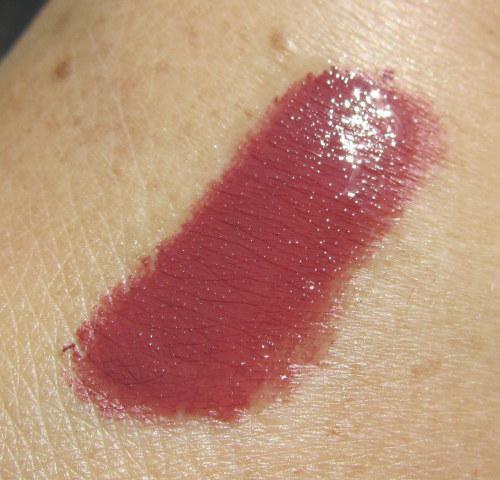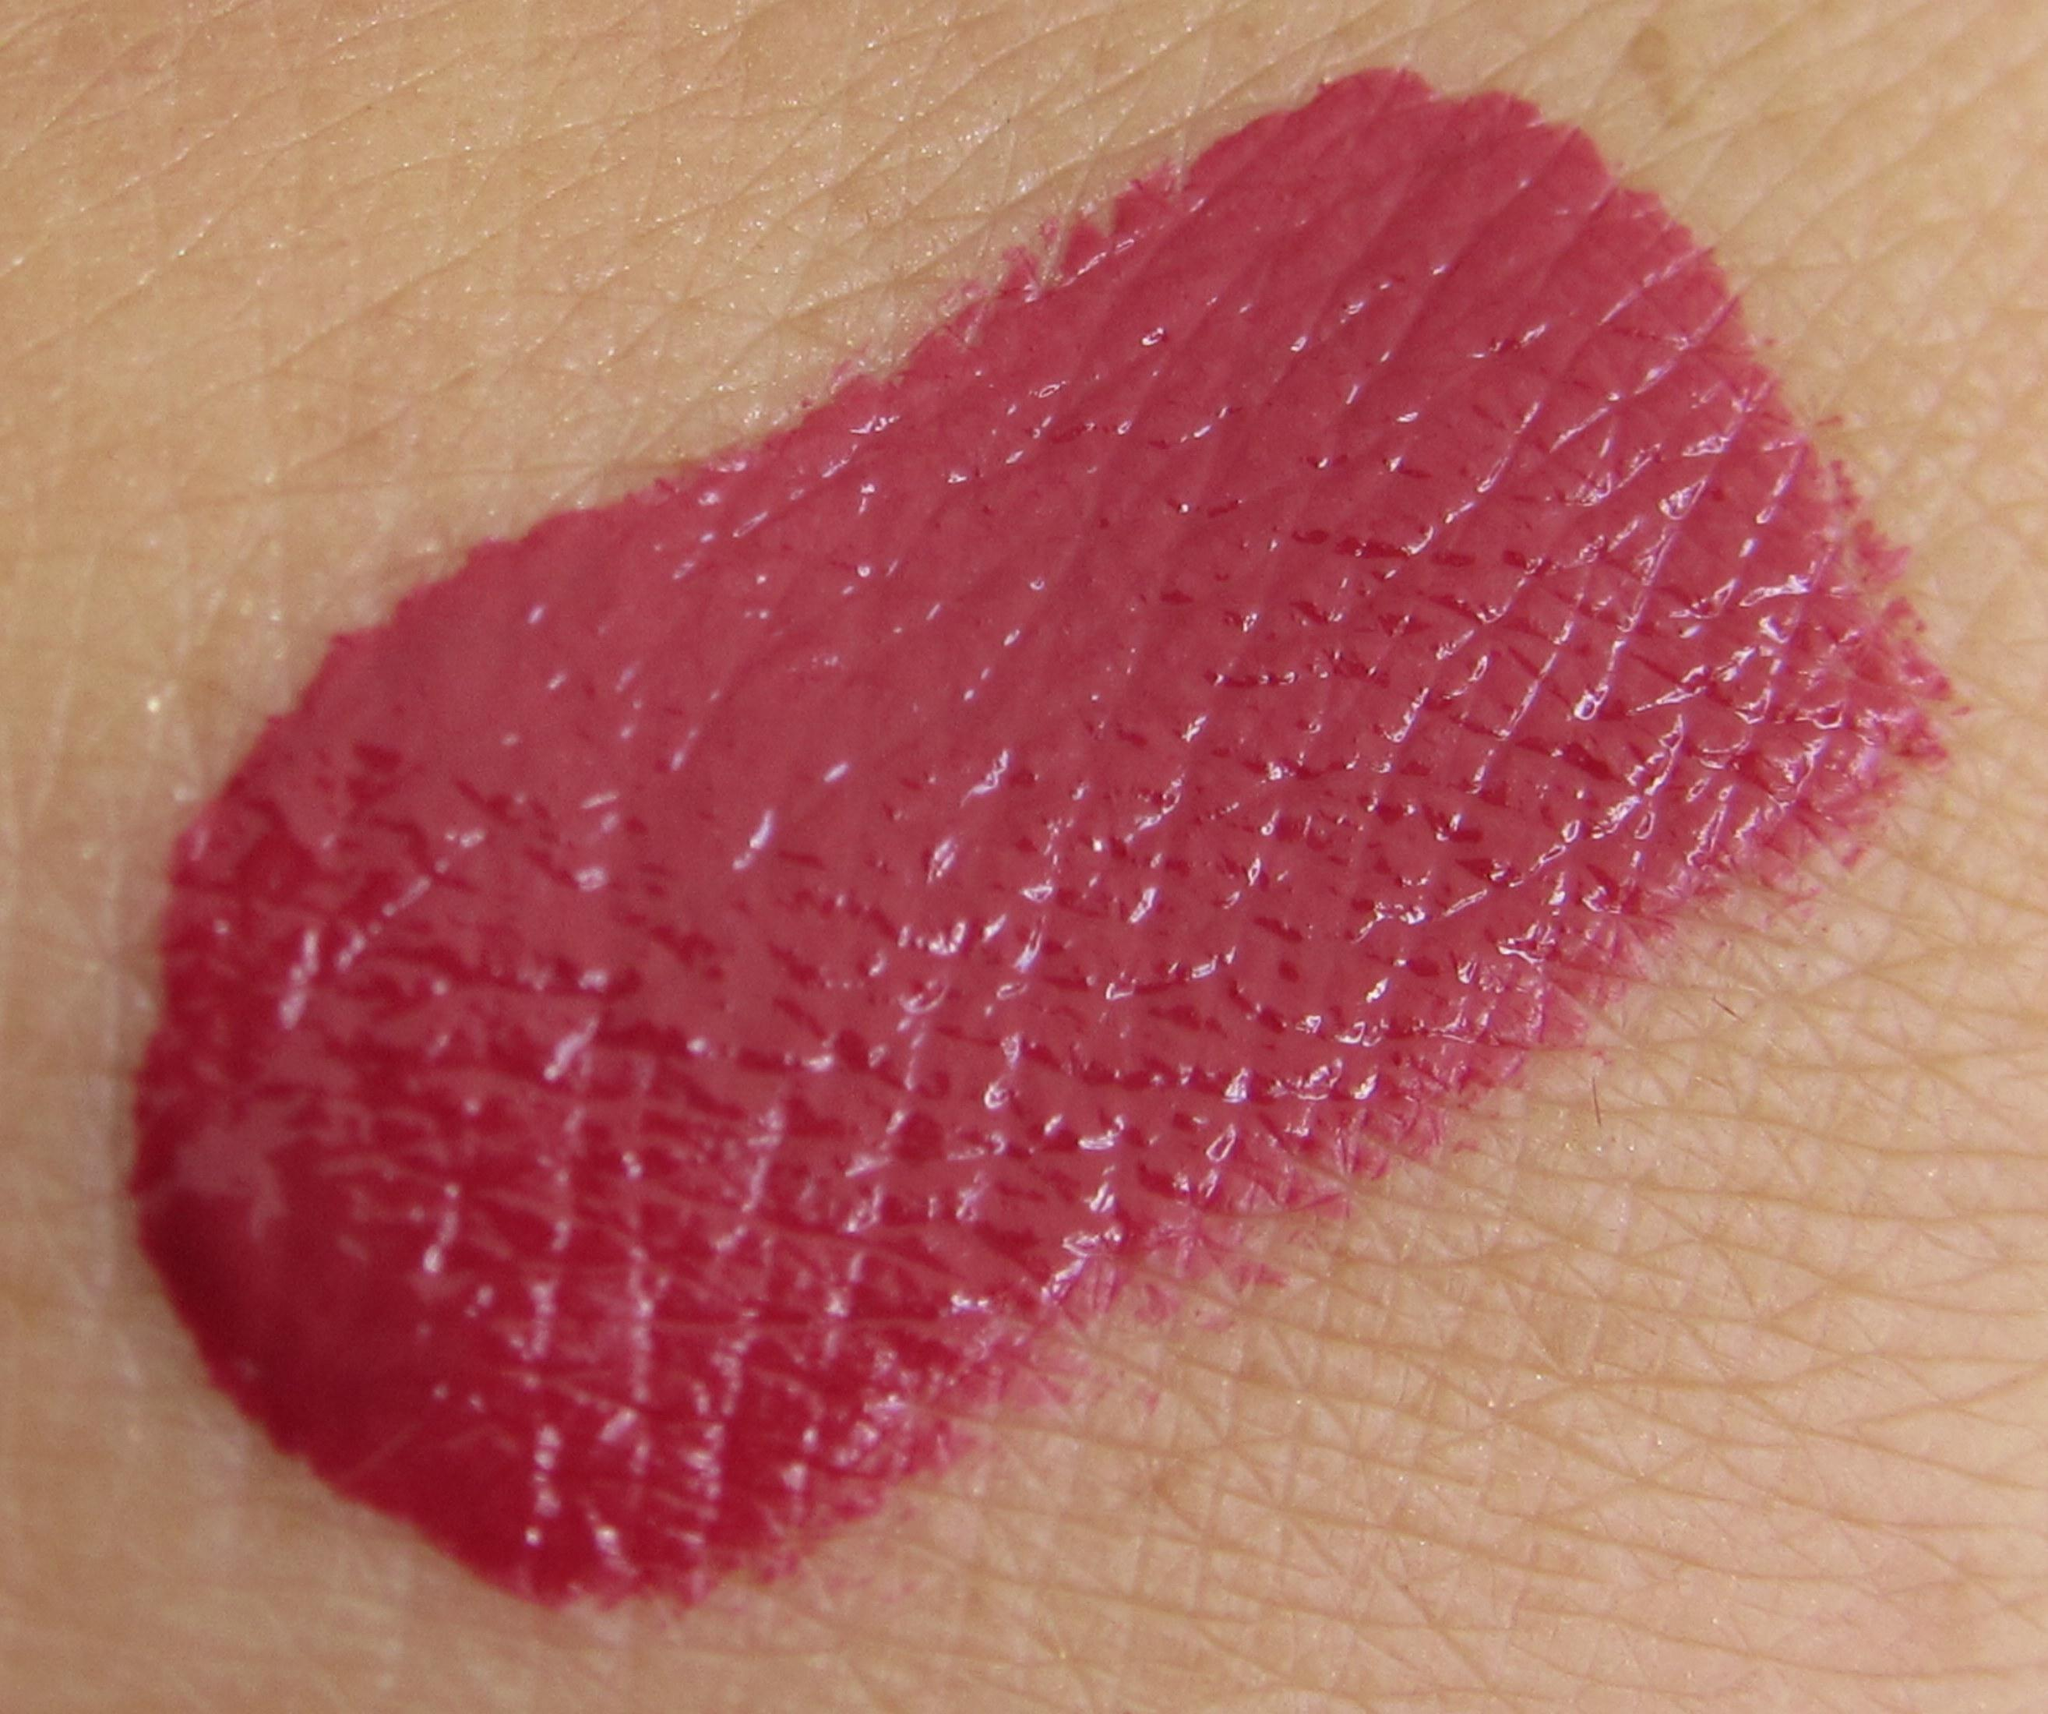The first image is the image on the left, the second image is the image on the right. Considering the images on both sides, is "The right image contains human lips with lipstick on them." valid? Answer yes or no. No. The first image is the image on the left, the second image is the image on the right. For the images displayed, is the sentence "A lipstick swatch is shown on a person's lip in both images." factually correct? Answer yes or no. No. 